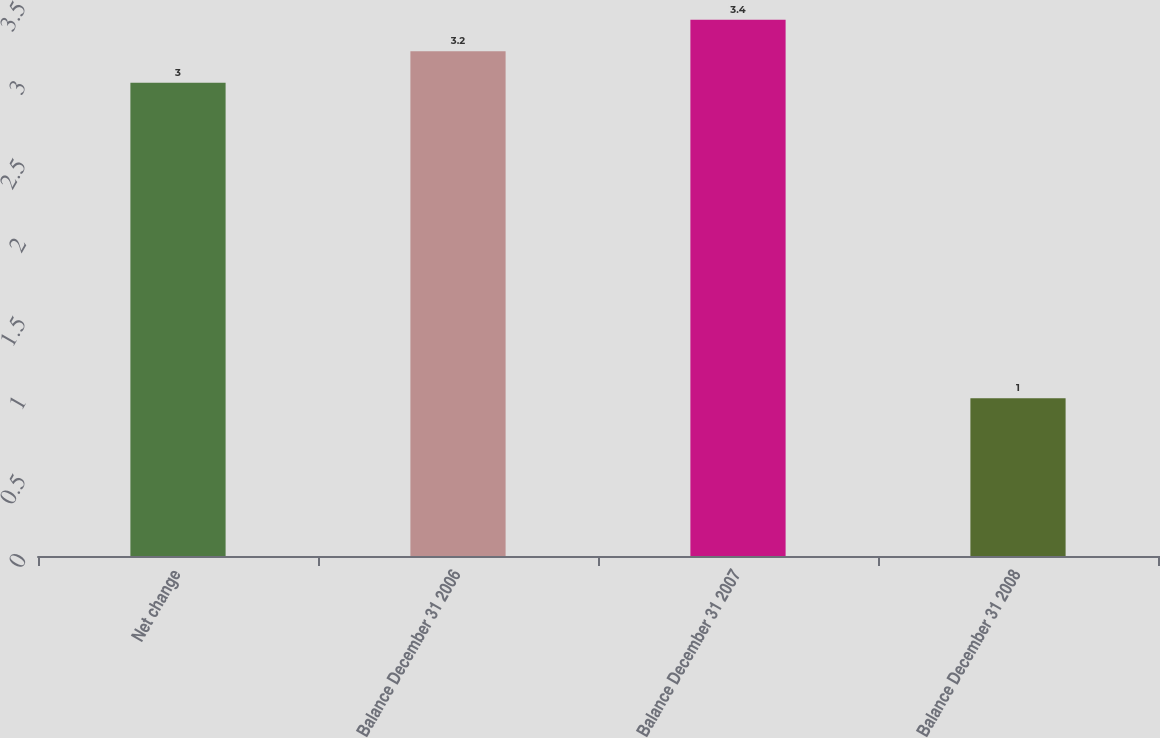Convert chart to OTSL. <chart><loc_0><loc_0><loc_500><loc_500><bar_chart><fcel>Net change<fcel>Balance December 31 2006<fcel>Balance December 31 2007<fcel>Balance December 31 2008<nl><fcel>3<fcel>3.2<fcel>3.4<fcel>1<nl></chart> 